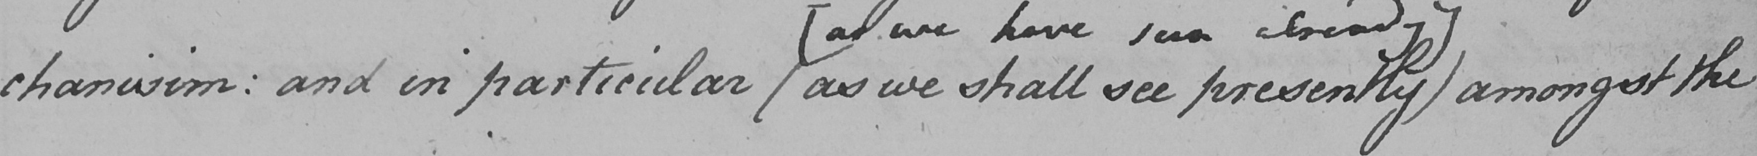Please provide the text content of this handwritten line. -chanisim :  and in particular  ( as we shall see presently  ]  amongst the 